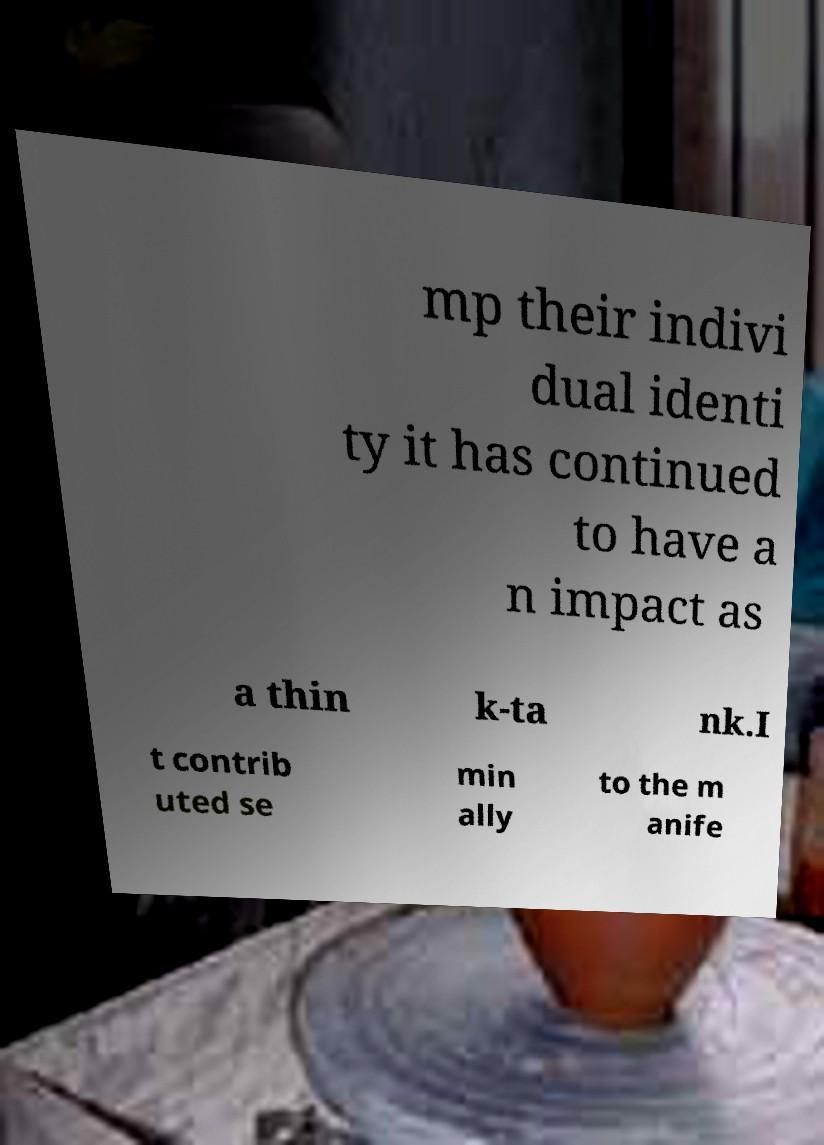Please identify and transcribe the text found in this image. mp their indivi dual identi ty it has continued to have a n impact as a thin k-ta nk.I t contrib uted se min ally to the m anife 